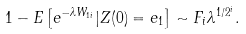<formula> <loc_0><loc_0><loc_500><loc_500>1 - E \left [ e ^ { - \lambda W _ { 1 i } } | Z ( 0 ) = e _ { 1 } \right ] \sim F _ { i } \lambda ^ { 1 / 2 ^ { i } } .</formula> 